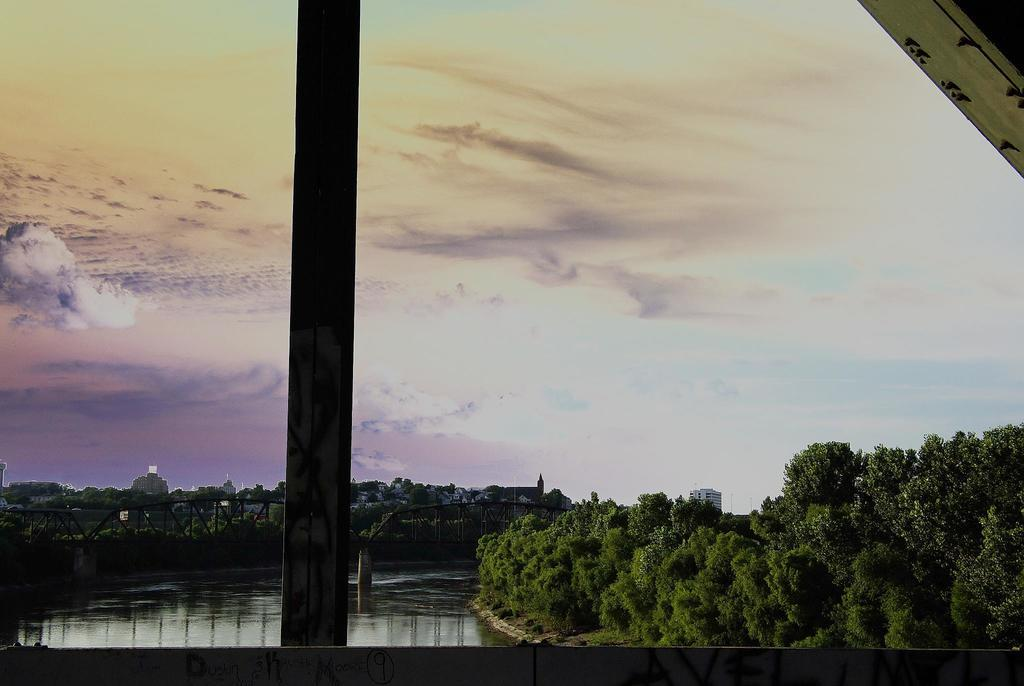What is present in the image that provides a view of the outdoors? There is a window in the image. What can be seen through the window? A lake and trees are visible through the window. What is the condition of the sky as seen through the window? The sky is visible through the window, and it is clouded. Can you see a wrench being used by someone in the image? There is no wrench or person using a wrench present in the image. Is there a dog visible through the window in the image? There is no dog visible through the window in the image. 